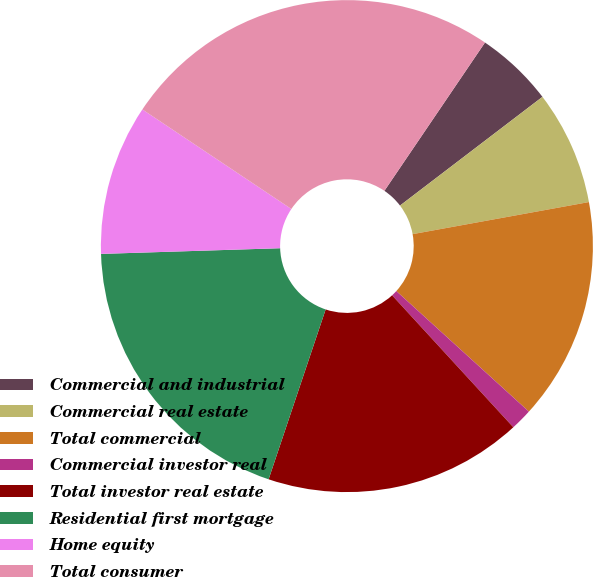Convert chart. <chart><loc_0><loc_0><loc_500><loc_500><pie_chart><fcel>Commercial and industrial<fcel>Commercial real estate<fcel>Total commercial<fcel>Commercial investor real<fcel>Total investor real estate<fcel>Residential first mortgage<fcel>Home equity<fcel>Total consumer<nl><fcel>5.14%<fcel>7.51%<fcel>14.61%<fcel>1.43%<fcel>16.98%<fcel>19.34%<fcel>9.88%<fcel>25.11%<nl></chart> 